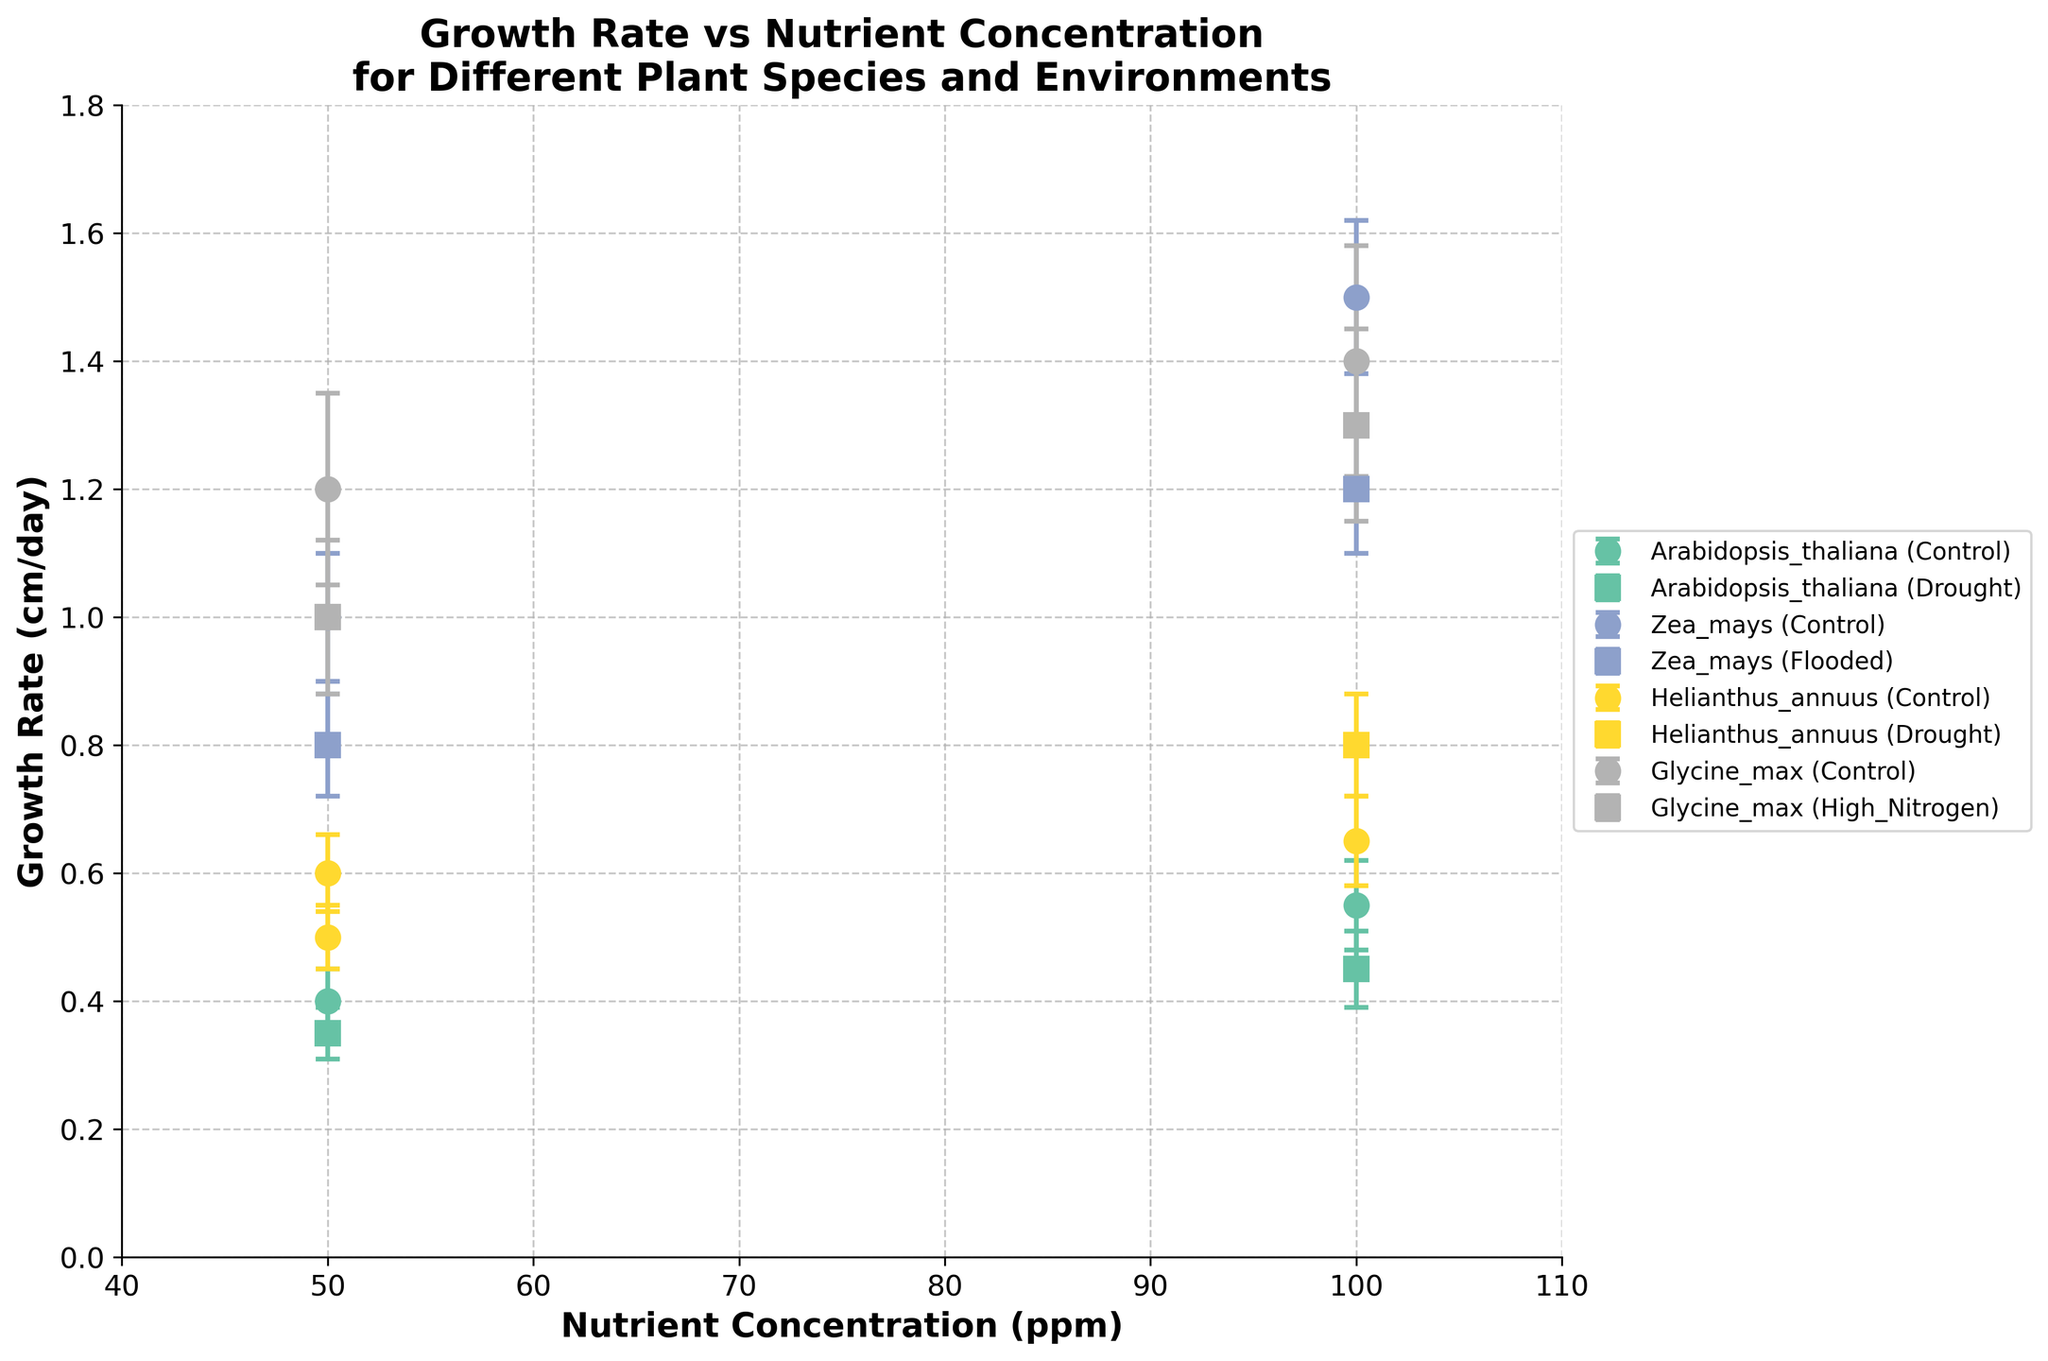What is the title of the figure? The title of a figure is typically displayed at the top and can be read directly from there.
Answer: Growth Rate vs Nutrient Concentration for Different Plant Species and Environments What is the range of the x-axis? The x-axis represents the nutrient concentration in ppm and has its range set from 40 to 110, as indicated by the axis limits in the plot.
Answer: 40 to 110 Which plant species has the highest growth rate at 100 ppm in a controlled environment? To find this information, look for the data points at 100 ppm under the "Control" environment for each species. Check which data point has the highest value on the y-axis.
Answer: Zea mays What is the average growth rate of Arabidopsis thaliana at 50 ppm across both environments? Arabidopsis thaliana has growth rates of 0.4 cm/day (Control) and 0.35 cm/day (Drought) at 50 ppm. The average is calculated as (0.4 + 0.35) / 2.
Answer: 0.375 cm/day How does the growth rate of Zea mays compare between the 50 ppm and 100 ppm nutrient levels in a controlled environment? Examine the growth rate of Zea mays at both 50 ppm and 100 ppm under the "Control" environment. At 50 ppm, the growth rate is 1.0 cm/day, and at 100 ppm, it is 1.5 cm/day.
Answer: The growth rate increases from 1.0 cm/day to 1.5 cm/day What are the error bar lengths for Helianthus annuus at 100 ppm in a drought environment? Error bars represent the standard deviation. For Helianthus annuus at 100 ppm under drought conditions, the error bar length equals the standard deviation, which is 0.08 cm/day.
Answer: 0.08 cm/day Which environment exhibits more variability for Glycine max at 50 ppm, Control or High Nitrogen? Variability is represented by the error bars. Compare the error bar lengths for Glycine max at 50 ppm in Control (0.15 cm/day) and High Nitrogen (0.12 cm/day).
Answer: Control Between Arabidopsis thaliana and Helianthus annuus, which species has a higher growth rate at 100 ppm in a control environment? Identify the growth rates for both species at 100 ppm in the control environment. Arabidopsis thaliana has a growth rate of 0.55 cm/day, while Helianthus annuus has 0.65 cm/day.
Answer: Helianthus annuus What is the difference in growth rate of Glycine max at 50 ppm between the Control and High Nitrogen environments? Glycine max has growth rates of 1.2 cm/day in Control and 1.0 cm/day in High Nitrogen at 50 ppm. The difference is calculated as 1.2 - 1.0.
Answer: 0.2 cm/day 